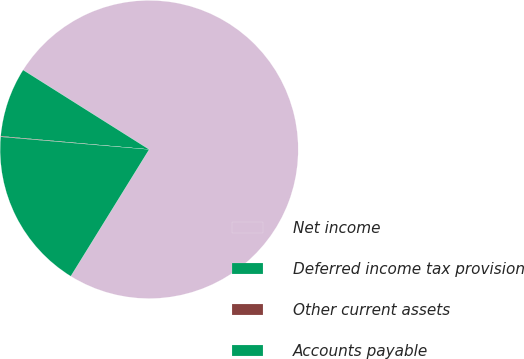Convert chart to OTSL. <chart><loc_0><loc_0><loc_500><loc_500><pie_chart><fcel>Net income<fcel>Deferred income tax provision<fcel>Other current assets<fcel>Accounts payable<nl><fcel>74.86%<fcel>7.54%<fcel>0.06%<fcel>17.54%<nl></chart> 